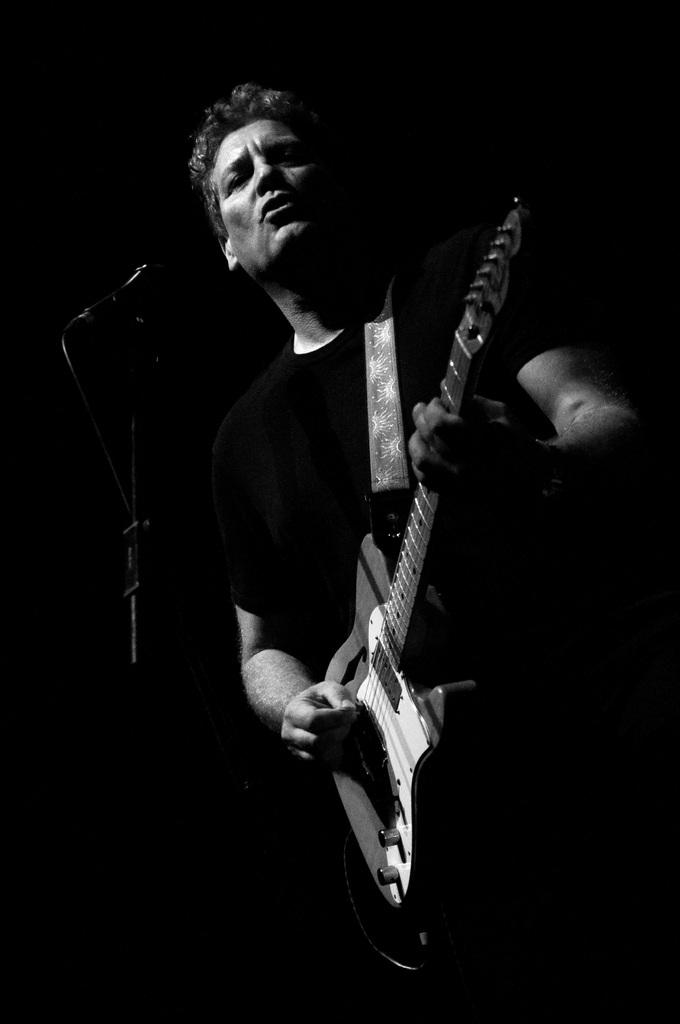What is the man in the image doing? The man is playing a guitar. Where is the man located in the image? The man is standing on a stage. What might the man be using to amplify his voice? There is a microphone in front of the man. What type of hose is the man using to play the guitar in the image? There is no hose present in the image, and the man is not using a hose to play the guitar. Is the man exchanging the guitar for a different instrument in the image? No, the man is not exchanging the guitar for a different instrument in the image; he is playing the guitar. --- 